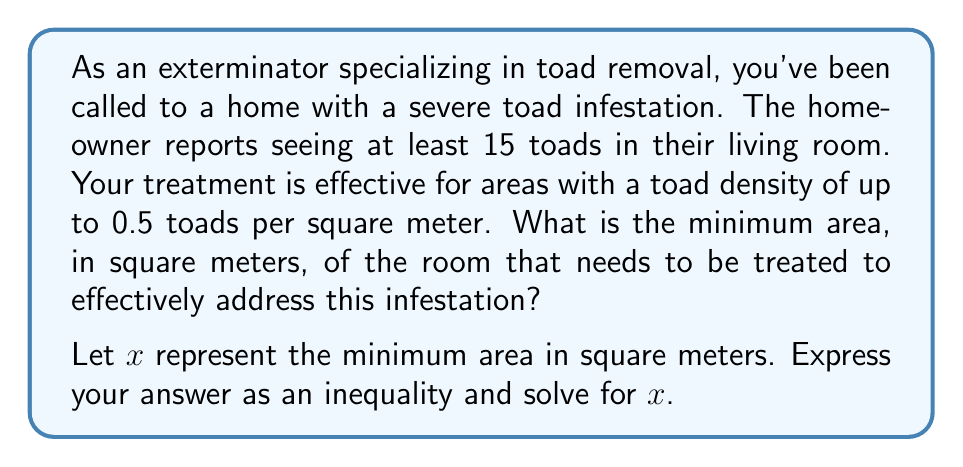Can you solve this math problem? To solve this problem, we need to set up an inequality based on the given information:

1) We know there are at least 15 toads in the room.
2) The treatment is effective for areas with a toad density of up to 0.5 toads per square meter.

Let's set up our inequality:

$$ \frac{\text{Number of toads}}{\text{Area in square meters}} \leq \text{Maximum effective density} $$

Plugging in our known values:

$$ \frac{15}{x} \leq 0.5 $$

Now, let's solve this inequality:

1) Multiply both sides by $x$:
   $$ 15 \leq 0.5x $$

2) Divide both sides by 0.5:
   $$ \frac{15}{0.5} \leq x $$

3) Simplify:
   $$ 30 \leq x $$

Therefore, the minimum area that needs to be treated is any area greater than or equal to 30 square meters.
Answer: $x \geq 30$ square meters 